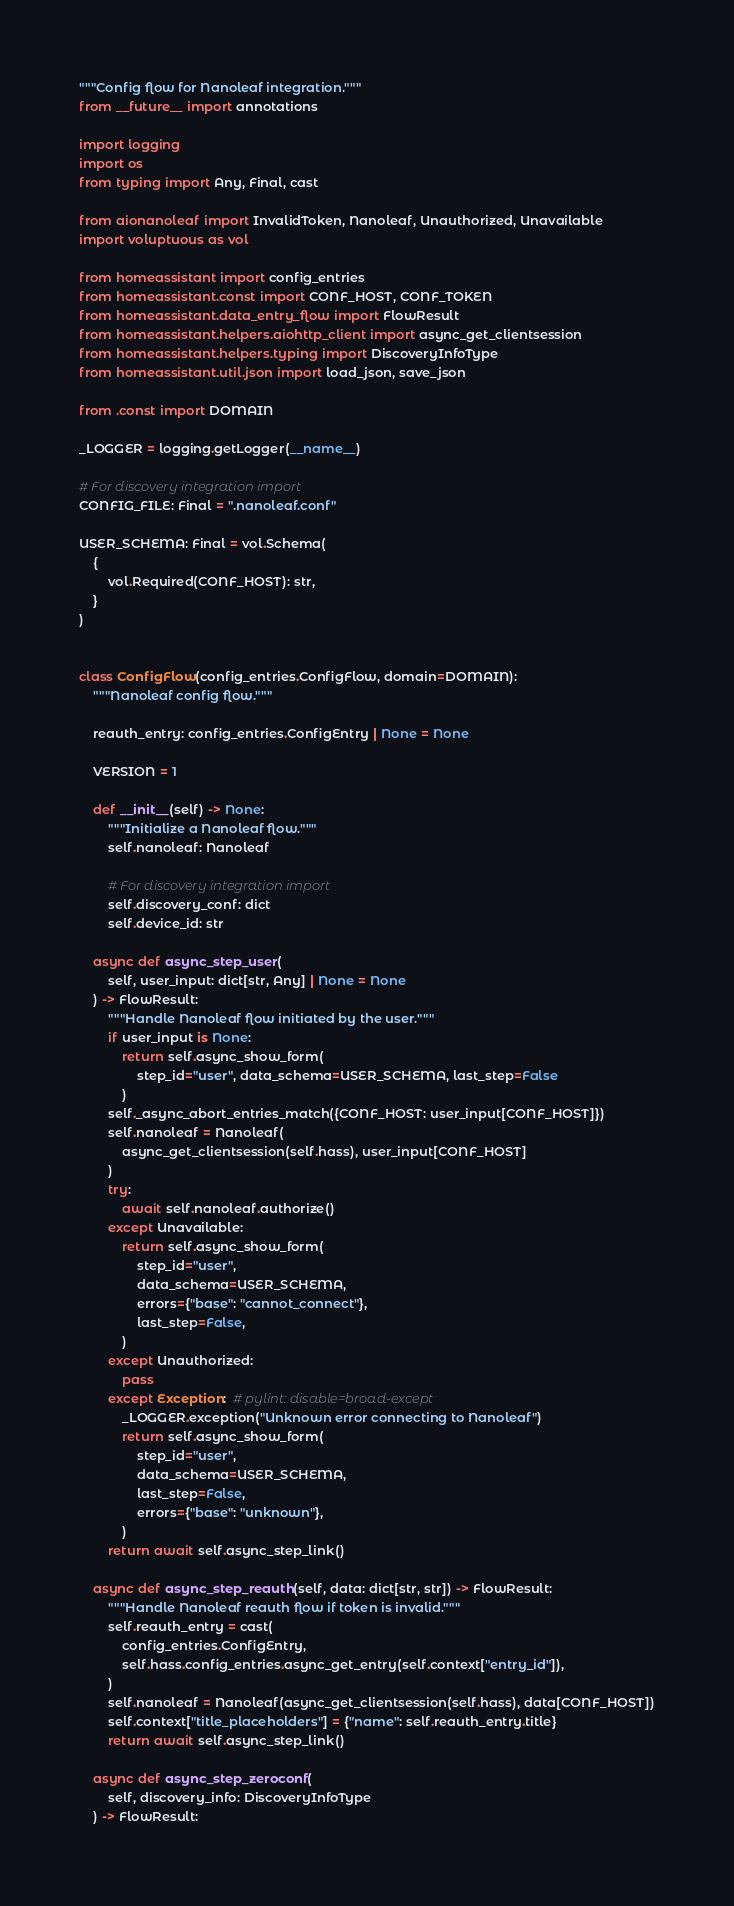Convert code to text. <code><loc_0><loc_0><loc_500><loc_500><_Python_>"""Config flow for Nanoleaf integration."""
from __future__ import annotations

import logging
import os
from typing import Any, Final, cast

from aionanoleaf import InvalidToken, Nanoleaf, Unauthorized, Unavailable
import voluptuous as vol

from homeassistant import config_entries
from homeassistant.const import CONF_HOST, CONF_TOKEN
from homeassistant.data_entry_flow import FlowResult
from homeassistant.helpers.aiohttp_client import async_get_clientsession
from homeassistant.helpers.typing import DiscoveryInfoType
from homeassistant.util.json import load_json, save_json

from .const import DOMAIN

_LOGGER = logging.getLogger(__name__)

# For discovery integration import
CONFIG_FILE: Final = ".nanoleaf.conf"

USER_SCHEMA: Final = vol.Schema(
    {
        vol.Required(CONF_HOST): str,
    }
)


class ConfigFlow(config_entries.ConfigFlow, domain=DOMAIN):
    """Nanoleaf config flow."""

    reauth_entry: config_entries.ConfigEntry | None = None

    VERSION = 1

    def __init__(self) -> None:
        """Initialize a Nanoleaf flow."""
        self.nanoleaf: Nanoleaf

        # For discovery integration import
        self.discovery_conf: dict
        self.device_id: str

    async def async_step_user(
        self, user_input: dict[str, Any] | None = None
    ) -> FlowResult:
        """Handle Nanoleaf flow initiated by the user."""
        if user_input is None:
            return self.async_show_form(
                step_id="user", data_schema=USER_SCHEMA, last_step=False
            )
        self._async_abort_entries_match({CONF_HOST: user_input[CONF_HOST]})
        self.nanoleaf = Nanoleaf(
            async_get_clientsession(self.hass), user_input[CONF_HOST]
        )
        try:
            await self.nanoleaf.authorize()
        except Unavailable:
            return self.async_show_form(
                step_id="user",
                data_schema=USER_SCHEMA,
                errors={"base": "cannot_connect"},
                last_step=False,
            )
        except Unauthorized:
            pass
        except Exception:  # pylint: disable=broad-except
            _LOGGER.exception("Unknown error connecting to Nanoleaf")
            return self.async_show_form(
                step_id="user",
                data_schema=USER_SCHEMA,
                last_step=False,
                errors={"base": "unknown"},
            )
        return await self.async_step_link()

    async def async_step_reauth(self, data: dict[str, str]) -> FlowResult:
        """Handle Nanoleaf reauth flow if token is invalid."""
        self.reauth_entry = cast(
            config_entries.ConfigEntry,
            self.hass.config_entries.async_get_entry(self.context["entry_id"]),
        )
        self.nanoleaf = Nanoleaf(async_get_clientsession(self.hass), data[CONF_HOST])
        self.context["title_placeholders"] = {"name": self.reauth_entry.title}
        return await self.async_step_link()

    async def async_step_zeroconf(
        self, discovery_info: DiscoveryInfoType
    ) -> FlowResult:</code> 